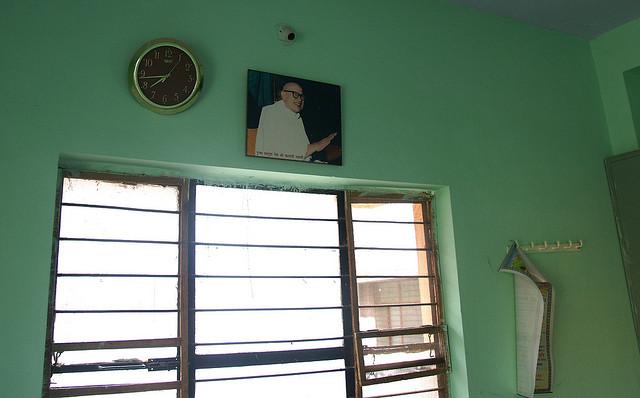Is this inside or outside?
Be succinct. Inside. What time of day is it?
Concise answer only. Morning. Is there a coat rack in the image?
Be succinct. Yes. What is the building made of?
Answer briefly. Wood. Are the blinds open?
Write a very short answer. Yes. What is to the right of the clock?
Answer briefly. Picture. 